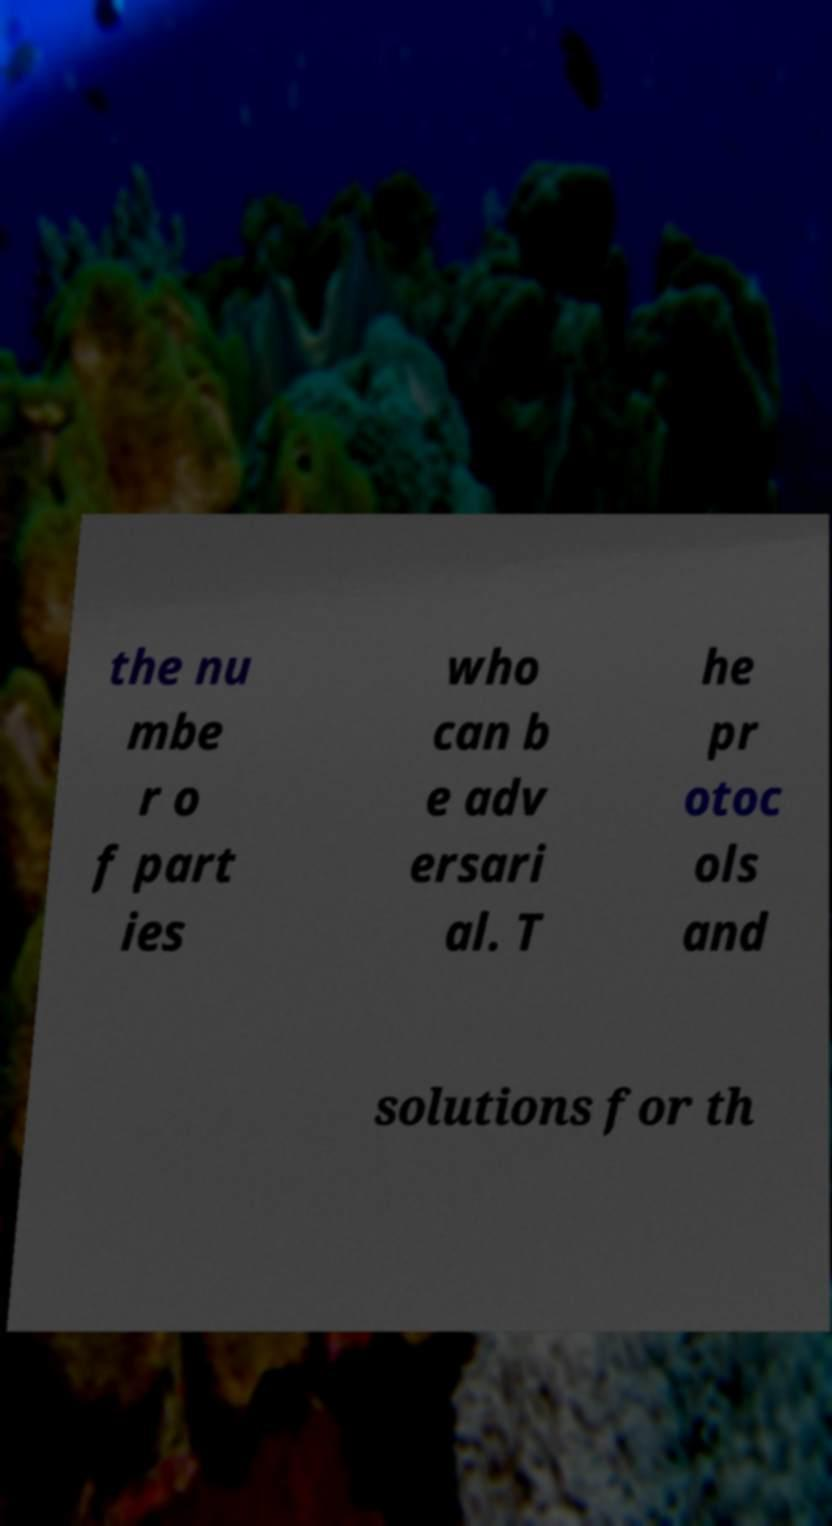What messages or text are displayed in this image? I need them in a readable, typed format. the nu mbe r o f part ies who can b e adv ersari al. T he pr otoc ols and solutions for th 